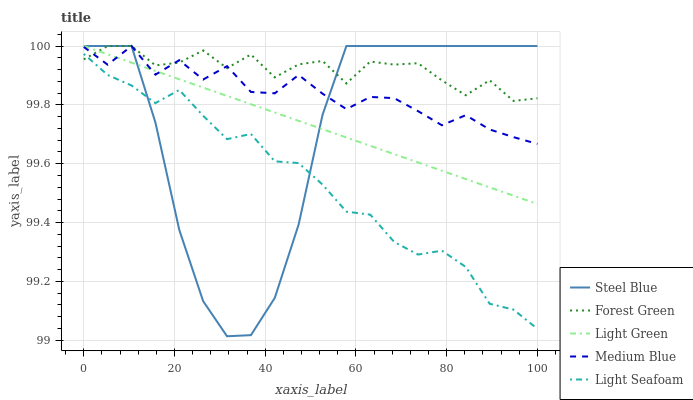Does Light Seafoam have the minimum area under the curve?
Answer yes or no. Yes. Does Forest Green have the maximum area under the curve?
Answer yes or no. Yes. Does Medium Blue have the minimum area under the curve?
Answer yes or no. No. Does Medium Blue have the maximum area under the curve?
Answer yes or no. No. Is Light Green the smoothest?
Answer yes or no. Yes. Is Steel Blue the roughest?
Answer yes or no. Yes. Is Light Seafoam the smoothest?
Answer yes or no. No. Is Light Seafoam the roughest?
Answer yes or no. No. Does Steel Blue have the lowest value?
Answer yes or no. Yes. Does Light Seafoam have the lowest value?
Answer yes or no. No. Does Light Green have the highest value?
Answer yes or no. Yes. Does Light Seafoam have the highest value?
Answer yes or no. No. Is Light Seafoam less than Light Green?
Answer yes or no. Yes. Is Medium Blue greater than Light Seafoam?
Answer yes or no. Yes. Does Forest Green intersect Light Green?
Answer yes or no. Yes. Is Forest Green less than Light Green?
Answer yes or no. No. Is Forest Green greater than Light Green?
Answer yes or no. No. Does Light Seafoam intersect Light Green?
Answer yes or no. No. 